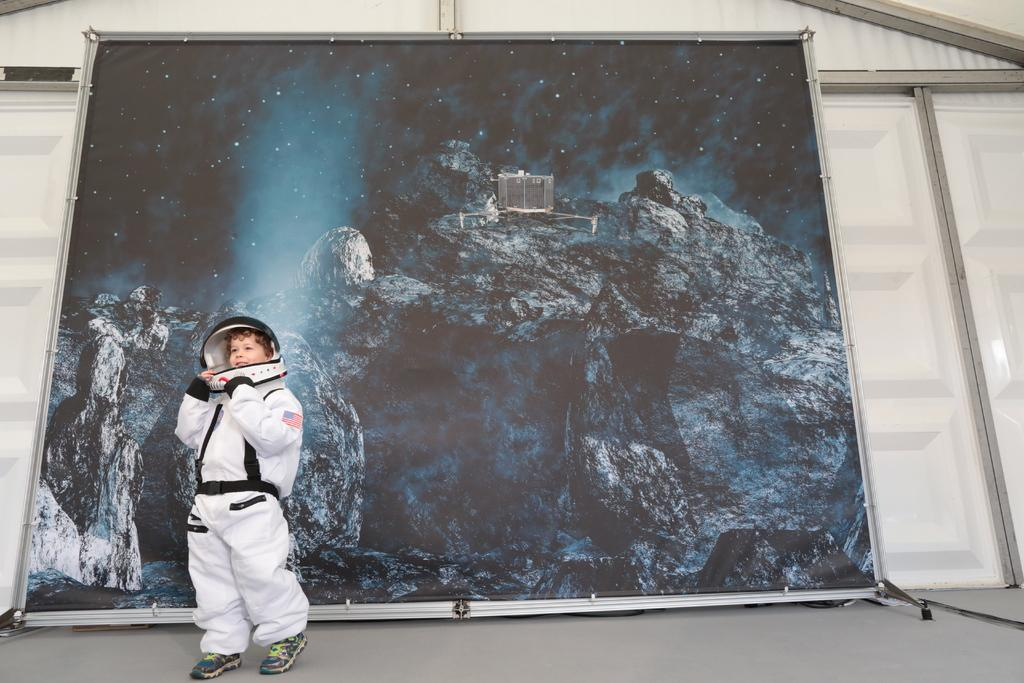What is the main subject of the image? The main subject of the image is a kid standing on the floor. What can be seen in the background of the image? There is a banner in the background of the image. What type of work does the kid do in the image? There is no indication of the kid doing any work in the image. What historical event is depicted in the image? There is no historical event depicted in the image; it simply shows a kid standing on the floor with a banner in the background. 